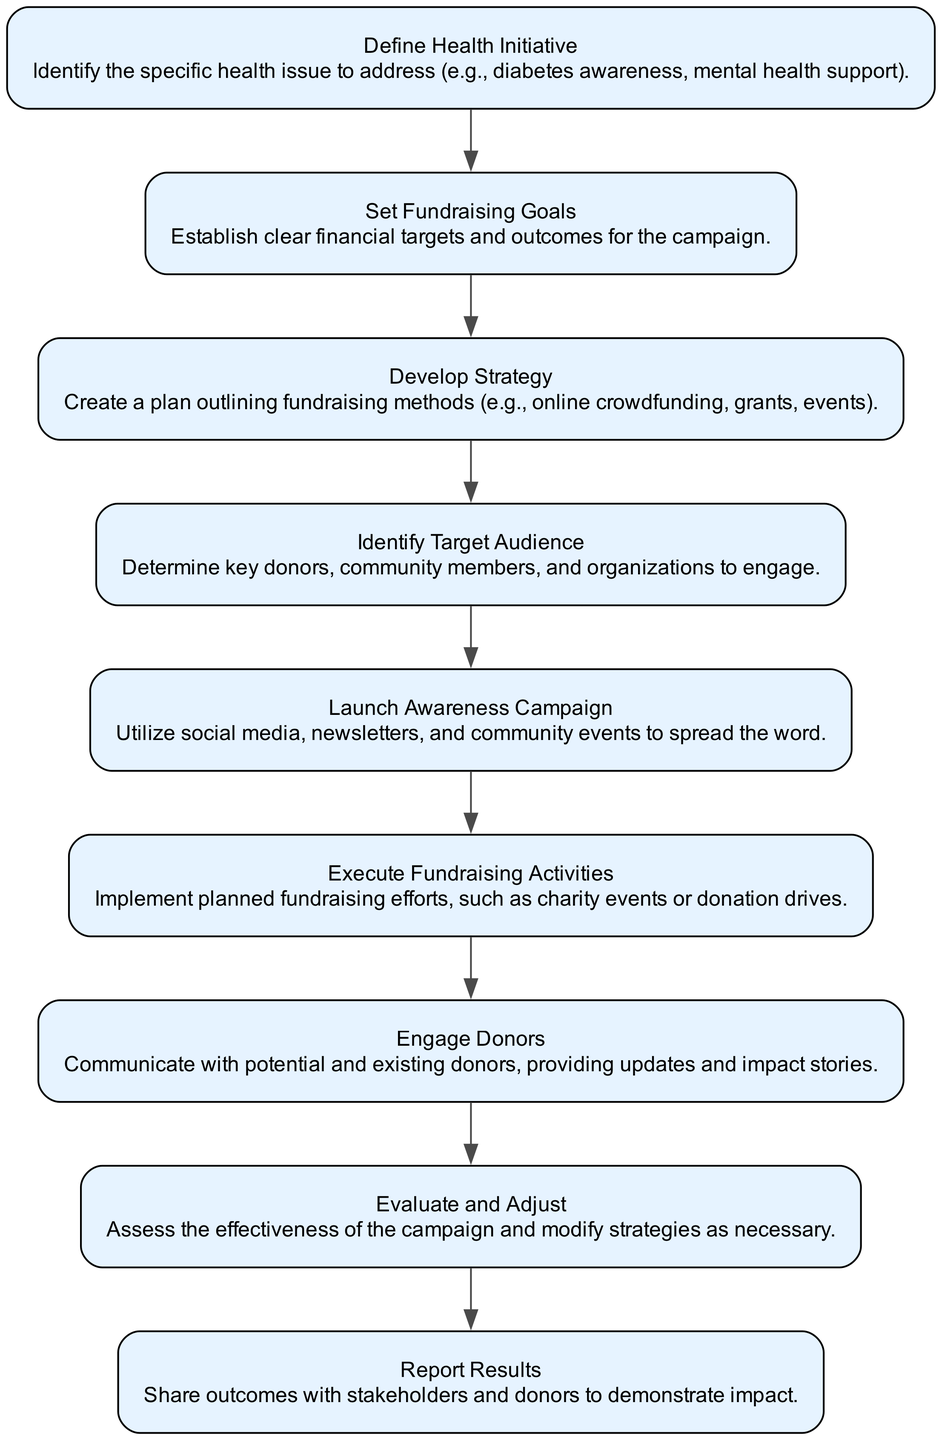What is the first step in the fundraising process? The first step in the process is to "Define Health Initiative," which refers to identifying the specific health issue to address.
Answer: Define Health Initiative How many total nodes are in the diagram? The diagram contains a total of 9 nodes, each representing a step in the fundraising process from defining the initiative to reporting results.
Answer: 9 What follows after "Set Fundraising Goals"? After "Set Fundraising Goals," the next step is "Develop Strategy," which involves creating a plan for fundraising methods.
Answer: Develop Strategy Which step involves communicating with donors? The step that involves communicating with donors is "Engage Donors," where updates and impact stories are shared with potential and existing donors.
Answer: Engage Donors What is the purpose of "Evaluate and Adjust"? The purpose of "Evaluate and Adjust" is to assess the effectiveness of the campaign and modify strategies as necessary based on the evaluation.
Answer: Assess the effectiveness How are the steps in the fundraising process connected? The steps are connected sequentially, indicating a flow from one step to the next, starting from defining the initiative to reporting results, following a linear progression without branching paths.
Answer: Sequentially connected What is the last action taken in this fundraising process? The last action taken in the fundraising process is "Report Results," where outcomes are shared with stakeholders and donors to demonstrate impact.
Answer: Report Results Which step comes immediately before "Launch Awareness Campaign"? The step that comes immediately before "Launch Awareness Campaign" is "Identify Target Audience," where key donors and community members are determined.
Answer: Identify Target Audience What is the focus of the "Develop Strategy" step? The focus of the "Develop Strategy" step is to create a plan outlining specific fundraising methods such as online crowdfunding, grants, or events.
Answer: Create a plan outlining fundraising methods 